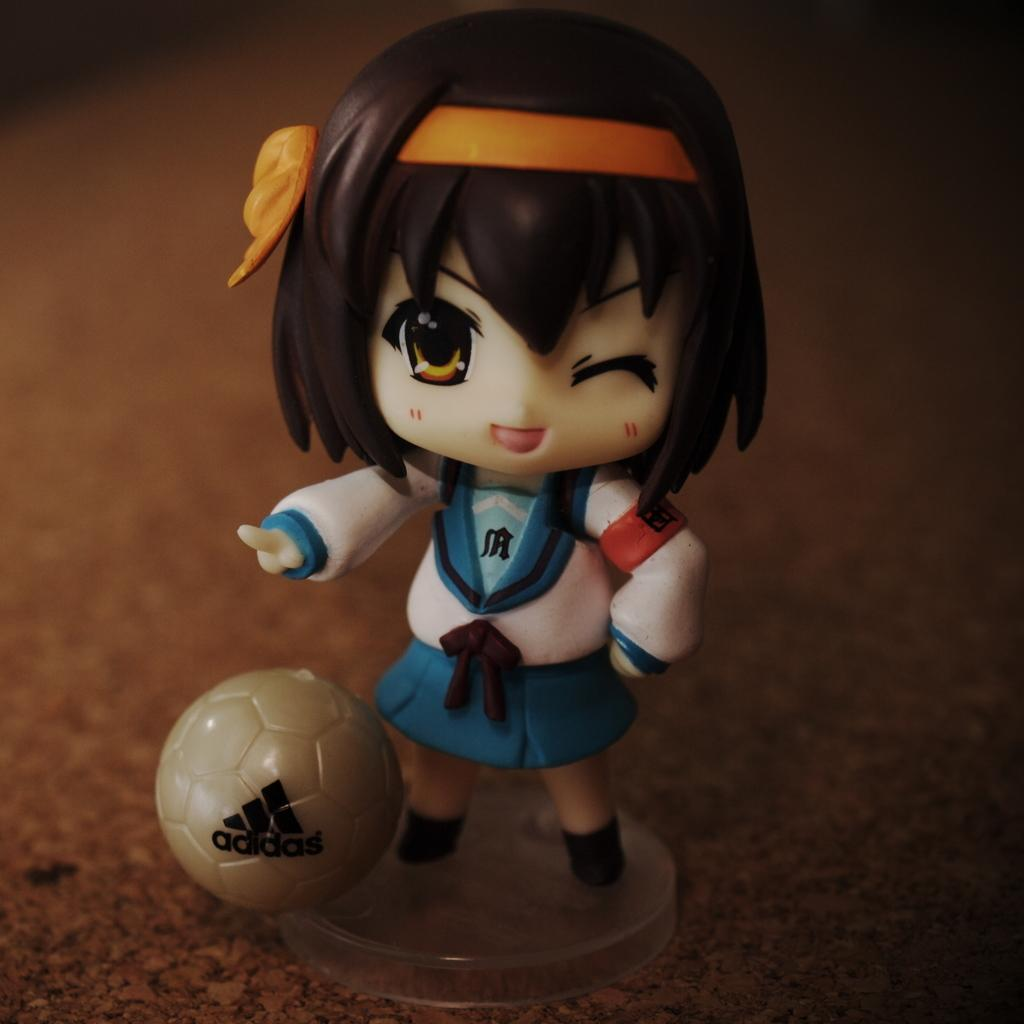What is the main subject of the image? The main subject of the image is a toy girl. What is the toy girl wearing? The toy girl is wearing a white and blue color dress. What other object can be seen in the image? There is a brown color ball in the image. What is the color of the background in the image? The background of the image is brown in color. What type of reward is the toy girl receiving in the image? There is no indication in the image that the toy girl is receiving any reward. 